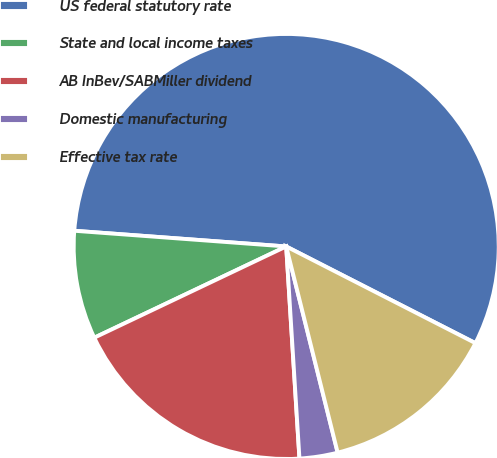Convert chart to OTSL. <chart><loc_0><loc_0><loc_500><loc_500><pie_chart><fcel>US federal statutory rate<fcel>State and local income taxes<fcel>AB InBev/SABMiller dividend<fcel>Domestic manufacturing<fcel>Effective tax rate<nl><fcel>56.34%<fcel>8.24%<fcel>18.93%<fcel>2.9%<fcel>13.59%<nl></chart> 